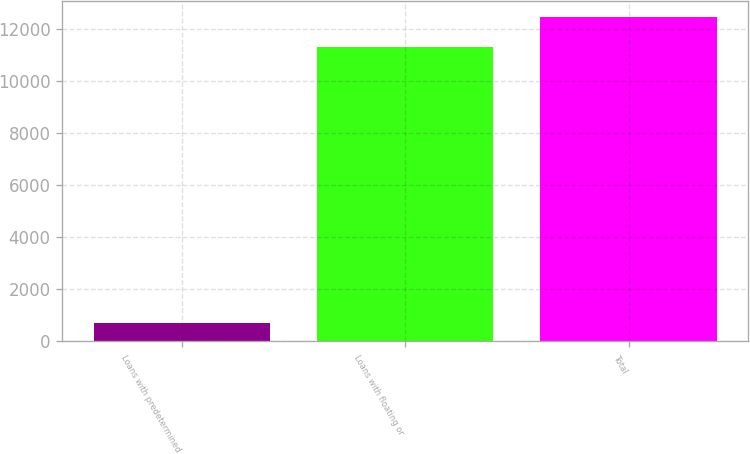Convert chart. <chart><loc_0><loc_0><loc_500><loc_500><bar_chart><fcel>Loans with predetermined<fcel>Loans with floating or<fcel>Total<nl><fcel>716<fcel>11303<fcel>12433.3<nl></chart> 